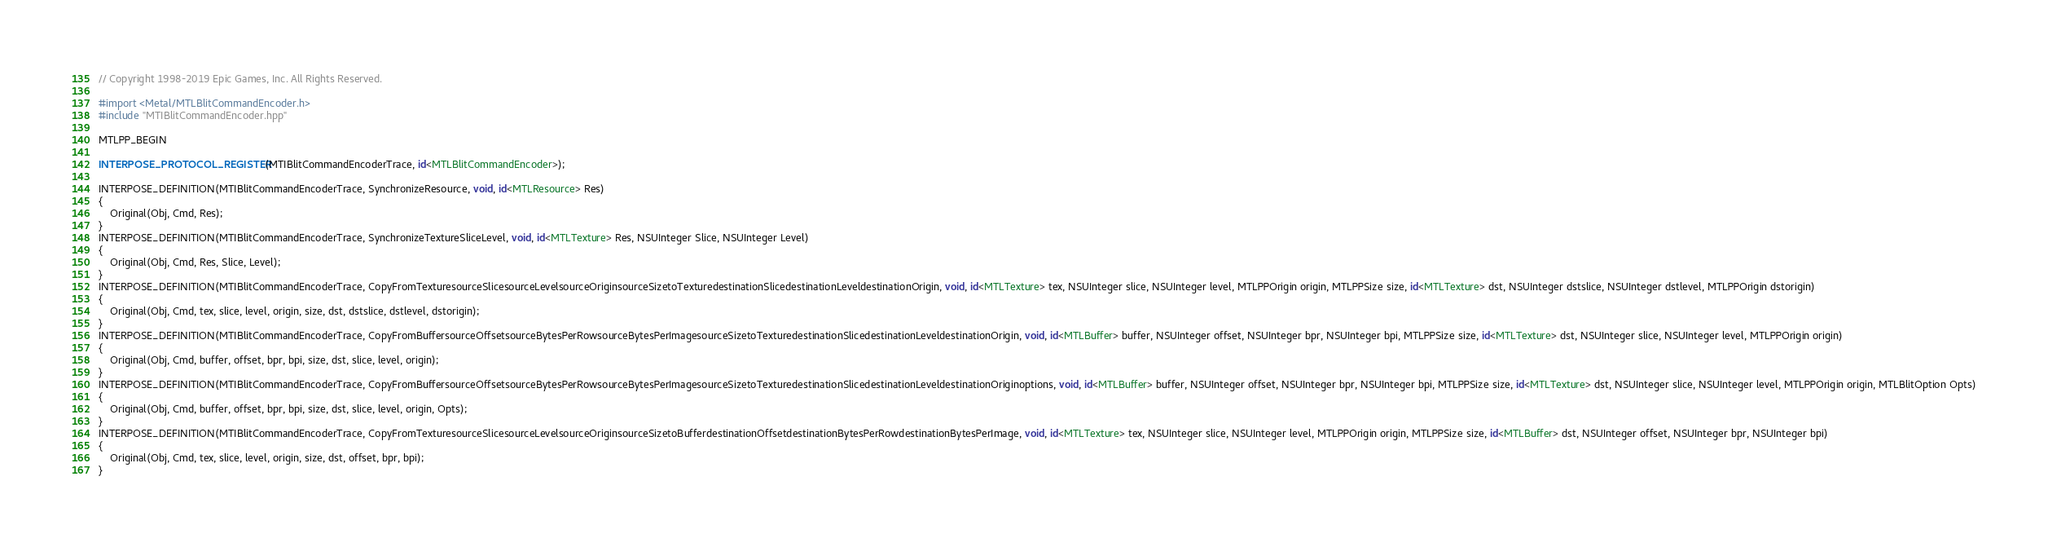<code> <loc_0><loc_0><loc_500><loc_500><_ObjectiveC_>// Copyright 1998-2019 Epic Games, Inc. All Rights Reserved.

#import <Metal/MTLBlitCommandEncoder.h>
#include "MTIBlitCommandEncoder.hpp"

MTLPP_BEGIN

INTERPOSE_PROTOCOL_REGISTER(MTIBlitCommandEncoderTrace, id<MTLBlitCommandEncoder>);

INTERPOSE_DEFINITION(MTIBlitCommandEncoderTrace, SynchronizeResource, void, id<MTLResource> Res)
{
	Original(Obj, Cmd, Res);
}
INTERPOSE_DEFINITION(MTIBlitCommandEncoderTrace, SynchronizeTextureSliceLevel, void, id<MTLTexture> Res, NSUInteger Slice, NSUInteger Level)
{
	Original(Obj, Cmd, Res, Slice, Level);
}
INTERPOSE_DEFINITION(MTIBlitCommandEncoderTrace, CopyFromTexturesourceSlicesourceLevelsourceOriginsourceSizetoTexturedestinationSlicedestinationLeveldestinationOrigin, void, id<MTLTexture> tex, NSUInteger slice, NSUInteger level, MTLPPOrigin origin, MTLPPSize size, id<MTLTexture> dst, NSUInteger dstslice, NSUInteger dstlevel, MTLPPOrigin dstorigin)
{
	Original(Obj, Cmd, tex, slice, level, origin, size, dst, dstslice, dstlevel, dstorigin);
}
INTERPOSE_DEFINITION(MTIBlitCommandEncoderTrace, CopyFromBuffersourceOffsetsourceBytesPerRowsourceBytesPerImagesourceSizetoTexturedestinationSlicedestinationLeveldestinationOrigin, void, id<MTLBuffer> buffer, NSUInteger offset, NSUInteger bpr, NSUInteger bpi, MTLPPSize size, id<MTLTexture> dst, NSUInteger slice, NSUInteger level, MTLPPOrigin origin)
{
	Original(Obj, Cmd, buffer, offset, bpr, bpi, size, dst, slice, level, origin);
}
INTERPOSE_DEFINITION(MTIBlitCommandEncoderTrace, CopyFromBuffersourceOffsetsourceBytesPerRowsourceBytesPerImagesourceSizetoTexturedestinationSlicedestinationLeveldestinationOriginoptions, void, id<MTLBuffer> buffer, NSUInteger offset, NSUInteger bpr, NSUInteger bpi, MTLPPSize size, id<MTLTexture> dst, NSUInteger slice, NSUInteger level, MTLPPOrigin origin, MTLBlitOption Opts)
{
	Original(Obj, Cmd, buffer, offset, bpr, bpi, size, dst, slice, level, origin, Opts);
}
INTERPOSE_DEFINITION(MTIBlitCommandEncoderTrace, CopyFromTexturesourceSlicesourceLevelsourceOriginsourceSizetoBufferdestinationOffsetdestinationBytesPerRowdestinationBytesPerImage, void, id<MTLTexture> tex, NSUInteger slice, NSUInteger level, MTLPPOrigin origin, MTLPPSize size, id<MTLBuffer> dst, NSUInteger offset, NSUInteger bpr, NSUInteger bpi)
{
	Original(Obj, Cmd, tex, slice, level, origin, size, dst, offset, bpr, bpi);
}</code> 